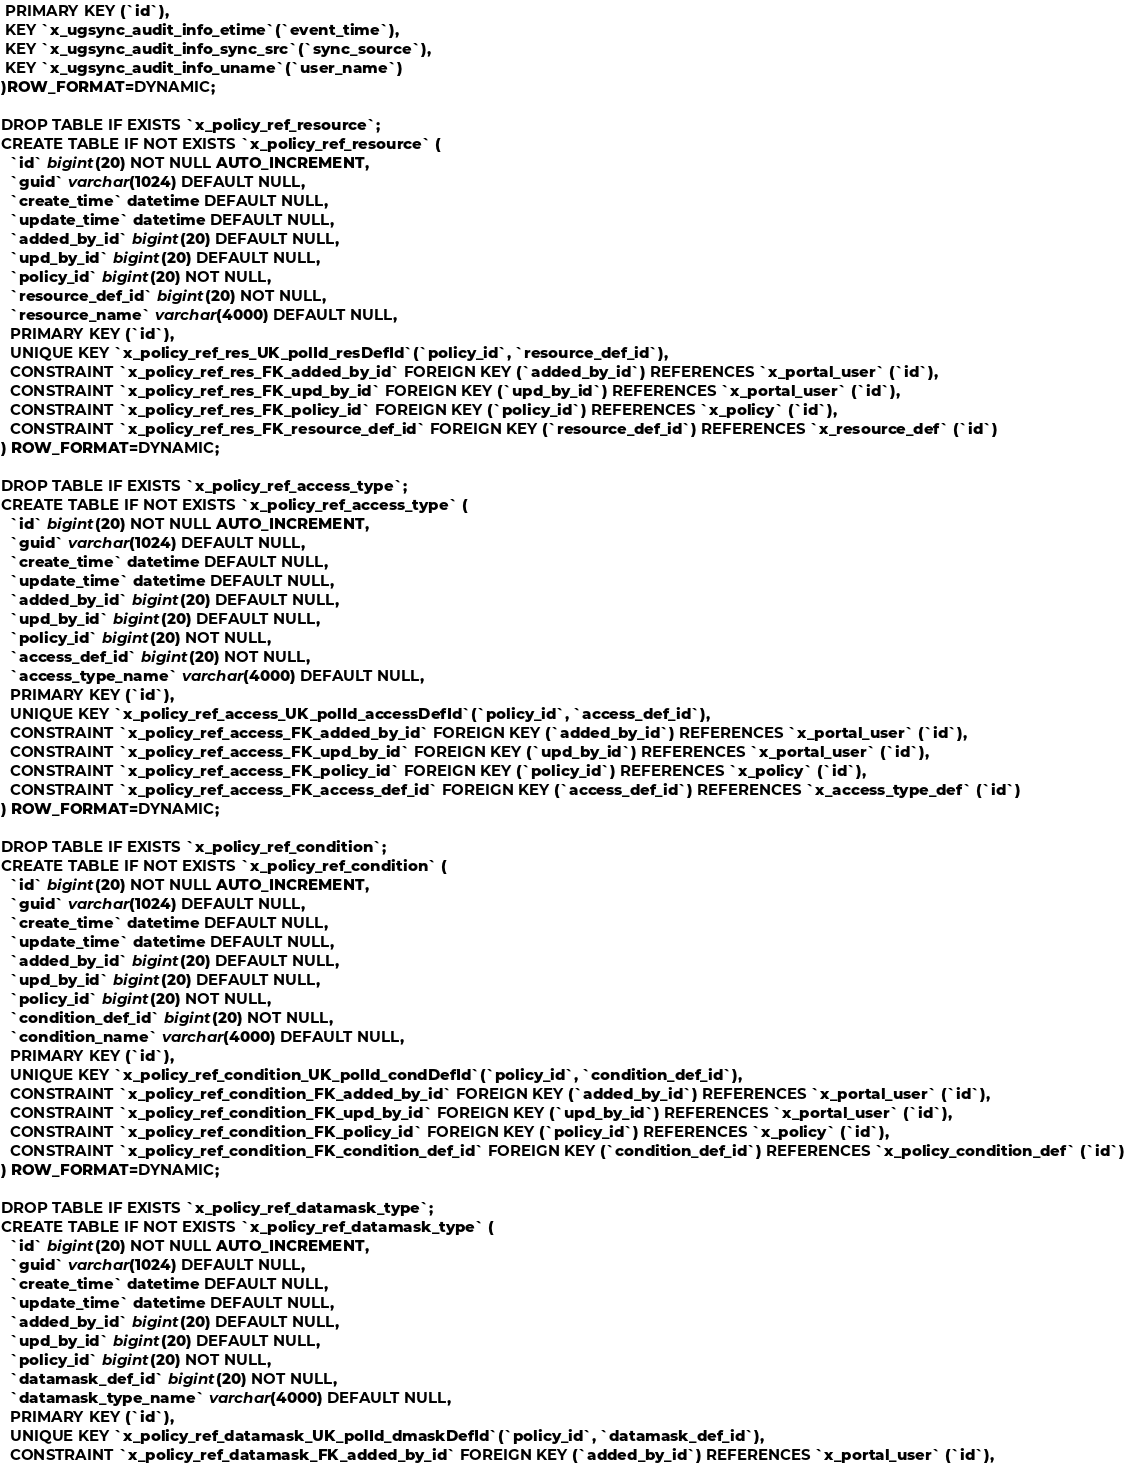<code> <loc_0><loc_0><loc_500><loc_500><_SQL_> PRIMARY KEY (`id`),
 KEY `x_ugsync_audit_info_etime`(`event_time`),
 KEY `x_ugsync_audit_info_sync_src`(`sync_source`),
 KEY `x_ugsync_audit_info_uname`(`user_name`)
)ROW_FORMAT=DYNAMIC;

DROP TABLE IF EXISTS `x_policy_ref_resource`;
CREATE TABLE IF NOT EXISTS `x_policy_ref_resource` (
  `id` bigint(20) NOT NULL AUTO_INCREMENT,
  `guid` varchar(1024) DEFAULT NULL,
  `create_time` datetime DEFAULT NULL,
  `update_time` datetime DEFAULT NULL,
  `added_by_id` bigint(20) DEFAULT NULL,
  `upd_by_id` bigint(20) DEFAULT NULL,
  `policy_id` bigint(20) NOT NULL,
  `resource_def_id` bigint(20) NOT NULL,
  `resource_name` varchar(4000) DEFAULT NULL,
  PRIMARY KEY (`id`),
  UNIQUE KEY `x_policy_ref_res_UK_polId_resDefId`(`policy_id`, `resource_def_id`),
  CONSTRAINT `x_policy_ref_res_FK_added_by_id` FOREIGN KEY (`added_by_id`) REFERENCES `x_portal_user` (`id`),
  CONSTRAINT `x_policy_ref_res_FK_upd_by_id` FOREIGN KEY (`upd_by_id`) REFERENCES `x_portal_user` (`id`),
  CONSTRAINT `x_policy_ref_res_FK_policy_id` FOREIGN KEY (`policy_id`) REFERENCES `x_policy` (`id`),
  CONSTRAINT `x_policy_ref_res_FK_resource_def_id` FOREIGN KEY (`resource_def_id`) REFERENCES `x_resource_def` (`id`)
) ROW_FORMAT=DYNAMIC;

DROP TABLE IF EXISTS `x_policy_ref_access_type`;
CREATE TABLE IF NOT EXISTS `x_policy_ref_access_type` (
  `id` bigint(20) NOT NULL AUTO_INCREMENT,
  `guid` varchar(1024) DEFAULT NULL,
  `create_time` datetime DEFAULT NULL,
  `update_time` datetime DEFAULT NULL,
  `added_by_id` bigint(20) DEFAULT NULL,
  `upd_by_id` bigint(20) DEFAULT NULL,
  `policy_id` bigint(20) NOT NULL,
  `access_def_id` bigint(20) NOT NULL,
  `access_type_name` varchar(4000) DEFAULT NULL,
  PRIMARY KEY (`id`),
  UNIQUE KEY `x_policy_ref_access_UK_polId_accessDefId`(`policy_id`, `access_def_id`),
  CONSTRAINT `x_policy_ref_access_FK_added_by_id` FOREIGN KEY (`added_by_id`) REFERENCES `x_portal_user` (`id`),
  CONSTRAINT `x_policy_ref_access_FK_upd_by_id` FOREIGN KEY (`upd_by_id`) REFERENCES `x_portal_user` (`id`),
  CONSTRAINT `x_policy_ref_access_FK_policy_id` FOREIGN KEY (`policy_id`) REFERENCES `x_policy` (`id`),
  CONSTRAINT `x_policy_ref_access_FK_access_def_id` FOREIGN KEY (`access_def_id`) REFERENCES `x_access_type_def` (`id`)
) ROW_FORMAT=DYNAMIC;

DROP TABLE IF EXISTS `x_policy_ref_condition`;
CREATE TABLE IF NOT EXISTS `x_policy_ref_condition` (
  `id` bigint(20) NOT NULL AUTO_INCREMENT,
  `guid` varchar(1024) DEFAULT NULL,
  `create_time` datetime DEFAULT NULL,
  `update_time` datetime DEFAULT NULL,
  `added_by_id` bigint(20) DEFAULT NULL,
  `upd_by_id` bigint(20) DEFAULT NULL,
  `policy_id` bigint(20) NOT NULL,
  `condition_def_id` bigint(20) NOT NULL,
  `condition_name` varchar(4000) DEFAULT NULL,
  PRIMARY KEY (`id`),
  UNIQUE KEY `x_policy_ref_condition_UK_polId_condDefId`(`policy_id`, `condition_def_id`),
  CONSTRAINT `x_policy_ref_condition_FK_added_by_id` FOREIGN KEY (`added_by_id`) REFERENCES `x_portal_user` (`id`),
  CONSTRAINT `x_policy_ref_condition_FK_upd_by_id` FOREIGN KEY (`upd_by_id`) REFERENCES `x_portal_user` (`id`),
  CONSTRAINT `x_policy_ref_condition_FK_policy_id` FOREIGN KEY (`policy_id`) REFERENCES `x_policy` (`id`),
  CONSTRAINT `x_policy_ref_condition_FK_condition_def_id` FOREIGN KEY (`condition_def_id`) REFERENCES `x_policy_condition_def` (`id`)
) ROW_FORMAT=DYNAMIC;

DROP TABLE IF EXISTS `x_policy_ref_datamask_type`;
CREATE TABLE IF NOT EXISTS `x_policy_ref_datamask_type` (
  `id` bigint(20) NOT NULL AUTO_INCREMENT,
  `guid` varchar(1024) DEFAULT NULL,
  `create_time` datetime DEFAULT NULL,
  `update_time` datetime DEFAULT NULL,
  `added_by_id` bigint(20) DEFAULT NULL,
  `upd_by_id` bigint(20) DEFAULT NULL,
  `policy_id` bigint(20) NOT NULL,
  `datamask_def_id` bigint(20) NOT NULL,
  `datamask_type_name` varchar(4000) DEFAULT NULL,
  PRIMARY KEY (`id`),
  UNIQUE KEY `x_policy_ref_datamask_UK_polId_dmaskDefId`(`policy_id`, `datamask_def_id`),
  CONSTRAINT `x_policy_ref_datamask_FK_added_by_id` FOREIGN KEY (`added_by_id`) REFERENCES `x_portal_user` (`id`),</code> 